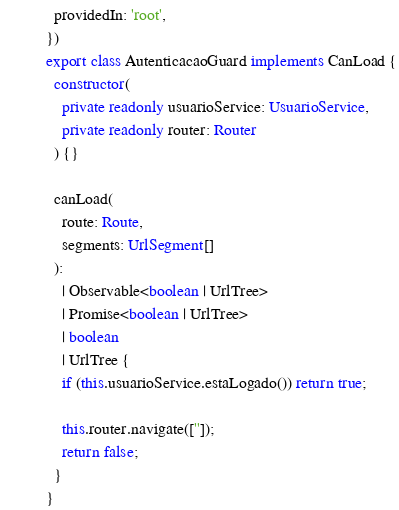Convert code to text. <code><loc_0><loc_0><loc_500><loc_500><_TypeScript_>  providedIn: 'root',
})
export class AutenticacaoGuard implements CanLoad {
  constructor(
    private readonly usuarioService: UsuarioService,
    private readonly router: Router
  ) {}

  canLoad(
    route: Route,
    segments: UrlSegment[]
  ):
    | Observable<boolean | UrlTree>
    | Promise<boolean | UrlTree>
    | boolean
    | UrlTree {
    if (this.usuarioService.estaLogado()) return true;

    this.router.navigate(['']);
    return false;
  }
}
</code> 